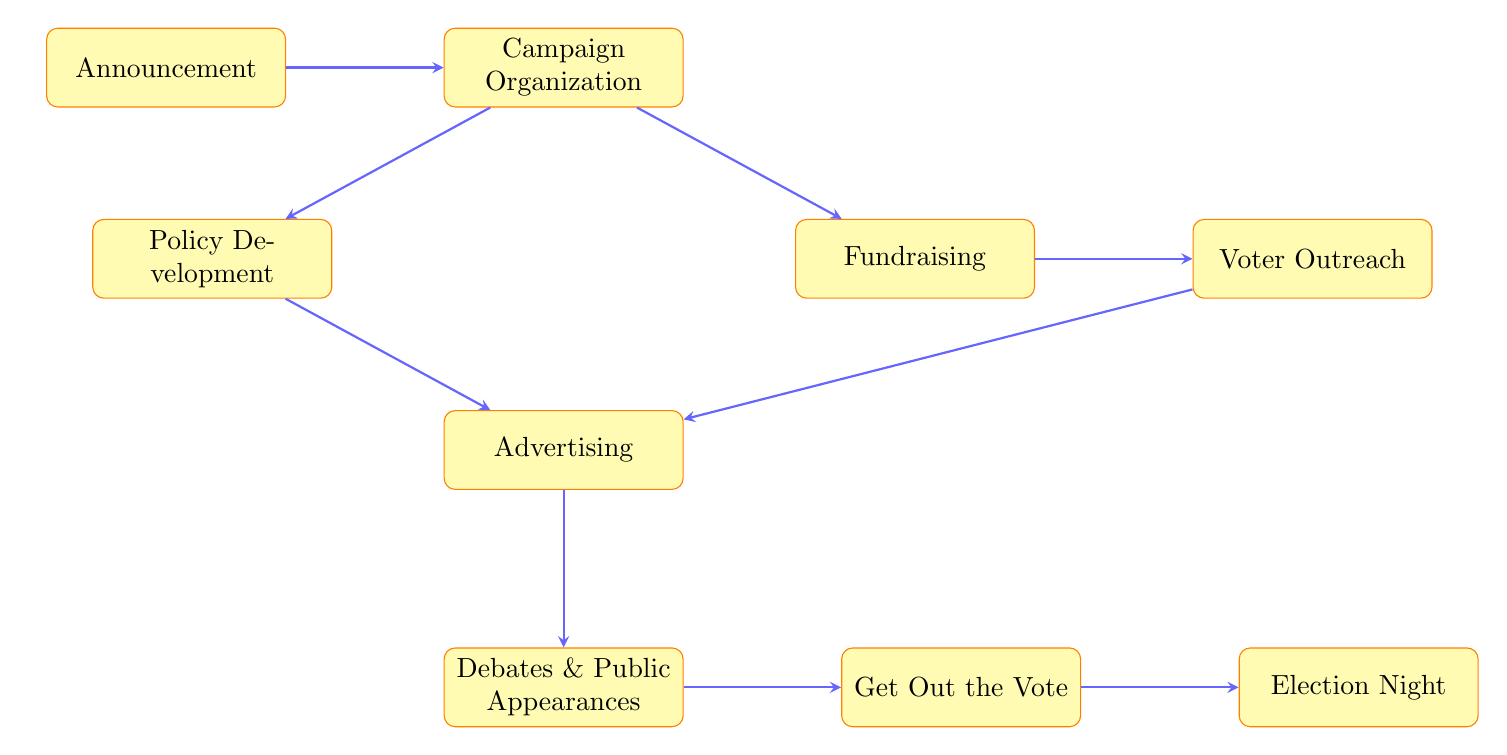What is the first stage of a political campaign? The first stage indicated in the diagram is "Announcement," which is the formal declaration of candidacy.
Answer: Announcement How many stages are there in this campaign flowchart? The diagram displays a total of nine distinct stages, including Announcement, Campaign Organization, Fundraising, Policy Development, Voter Outreach, Advertising, Debates and Public Appearances, Get Out the Vote, and Election Night.
Answer: Nine Which stage follows Campaign Organization? The next stage after Campaign Organization is Fundraising, signified by the directed arrow from Campaign Organization to Fundraising.
Answer: Fundraising Which two stages interact before Advertising? Before reaching the Advertising stage, the flow illustrates interactions with both Policy Development and Voter Outreach, leading to Advertising.
Answer: Policy Development and Voter Outreach What is the final outcome on Election Night? The final outcome indicated for Election Night is a "victory or concession speech," representing the actions taken after the vote results are monitored.
Answer: Victory or concession speech How does the Get Out the Vote stage connect to the preceding stage? The Get Out the Vote stage connects directly after Debates and Public Appearances, as depicted by the arrow leading from Debates to GOTV.
Answer: Directly connects What is required to take place after Fundraising and before Advertising? After Fundraising and before Advertising, both Policy Development and Voter Outreach need to be completed, as the arrows from Fundraising lead to Voter Outreach and Policy Development, indicating this sequence.
Answer: Policy Development and Voter Outreach What is the relationship between Debates and Election Night? The Debates and Public Appearances stage flows directly into the Get Out the Vote stage, which subsequently leads to Election Night, forming a sequential relationship towards the end of the campaign process.
Answer: Sequential relationship 